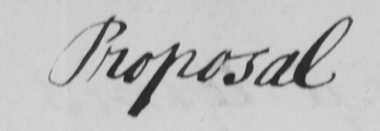Please transcribe the handwritten text in this image. Proposal 